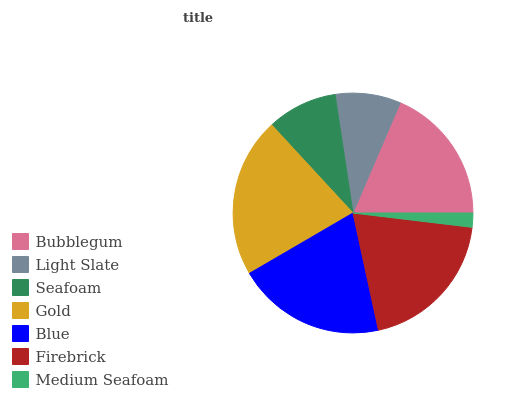Is Medium Seafoam the minimum?
Answer yes or no. Yes. Is Gold the maximum?
Answer yes or no. Yes. Is Light Slate the minimum?
Answer yes or no. No. Is Light Slate the maximum?
Answer yes or no. No. Is Bubblegum greater than Light Slate?
Answer yes or no. Yes. Is Light Slate less than Bubblegum?
Answer yes or no. Yes. Is Light Slate greater than Bubblegum?
Answer yes or no. No. Is Bubblegum less than Light Slate?
Answer yes or no. No. Is Bubblegum the high median?
Answer yes or no. Yes. Is Bubblegum the low median?
Answer yes or no. Yes. Is Seafoam the high median?
Answer yes or no. No. Is Medium Seafoam the low median?
Answer yes or no. No. 